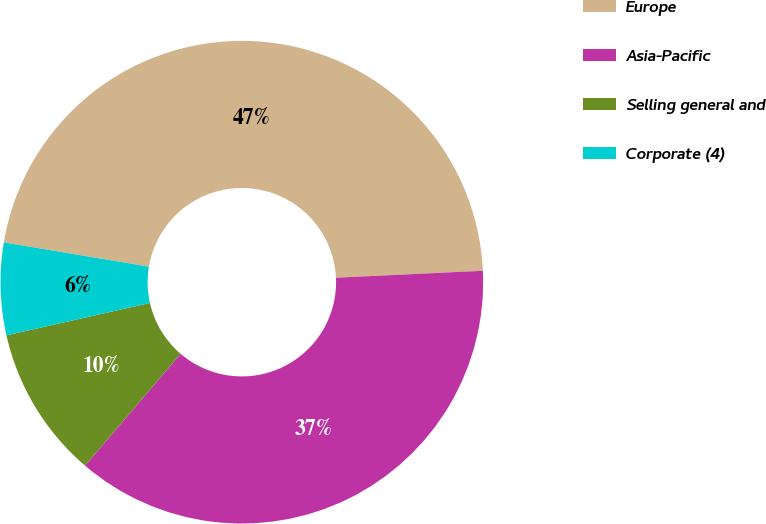Convert chart. <chart><loc_0><loc_0><loc_500><loc_500><pie_chart><fcel>Europe<fcel>Asia-Pacific<fcel>Selling general and<fcel>Corporate (4)<nl><fcel>46.61%<fcel>37.01%<fcel>10.21%<fcel>6.17%<nl></chart> 